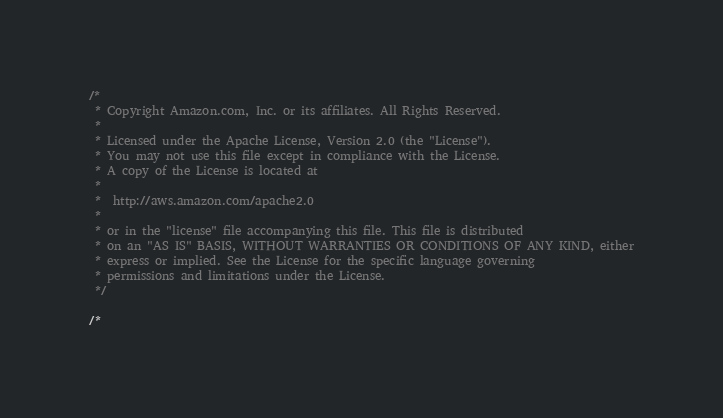Convert code to text. <code><loc_0><loc_0><loc_500><loc_500><_C#_>/*
 * Copyright Amazon.com, Inc. or its affiliates. All Rights Reserved.
 * 
 * Licensed under the Apache License, Version 2.0 (the "License").
 * You may not use this file except in compliance with the License.
 * A copy of the License is located at
 * 
 *  http://aws.amazon.com/apache2.0
 * 
 * or in the "license" file accompanying this file. This file is distributed
 * on an "AS IS" BASIS, WITHOUT WARRANTIES OR CONDITIONS OF ANY KIND, either
 * express or implied. See the License for the specific language governing
 * permissions and limitations under the License.
 */

/*</code> 